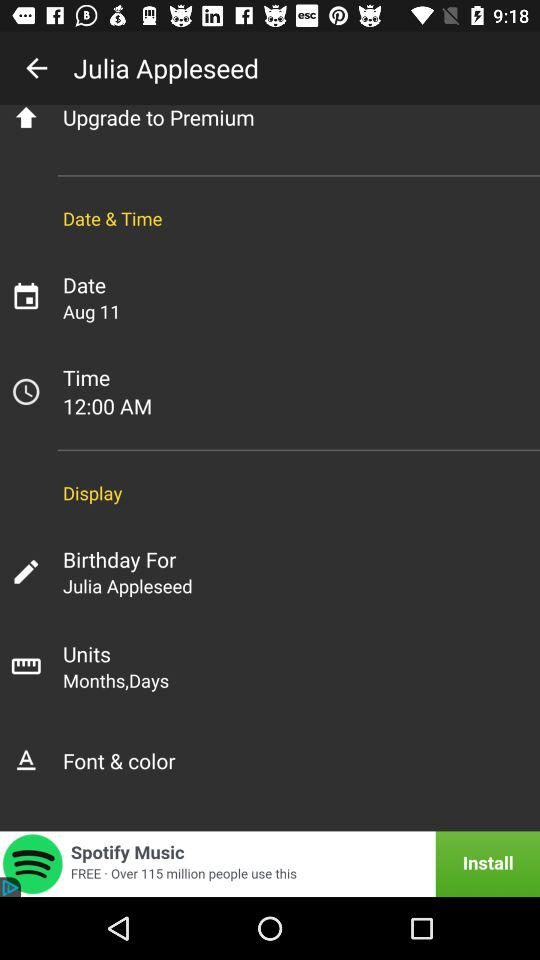What is the given date? The date is August 11. 